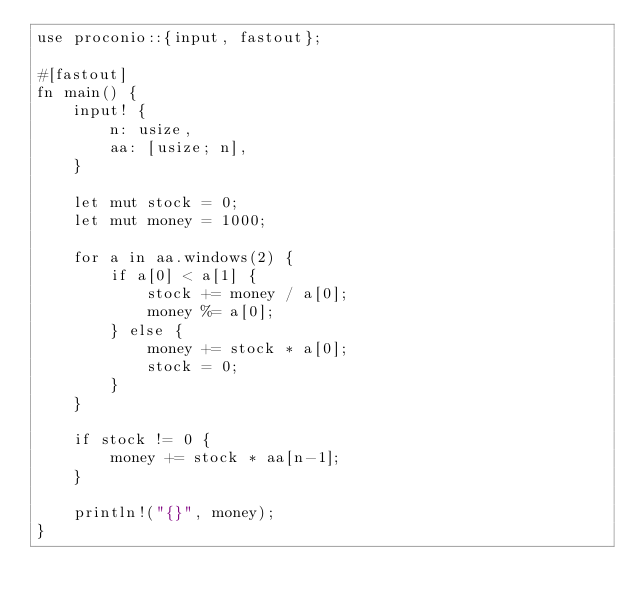Convert code to text. <code><loc_0><loc_0><loc_500><loc_500><_Rust_>use proconio::{input, fastout};

#[fastout]
fn main() {
    input! {
        n: usize,
        aa: [usize; n],
    }

    let mut stock = 0;
    let mut money = 1000;

    for a in aa.windows(2) {
        if a[0] < a[1] {
            stock += money / a[0];
            money %= a[0];
        } else {
            money += stock * a[0];
            stock = 0;
        }
    }

    if stock != 0 {
        money += stock * aa[n-1];
    }

    println!("{}", money);
}
</code> 